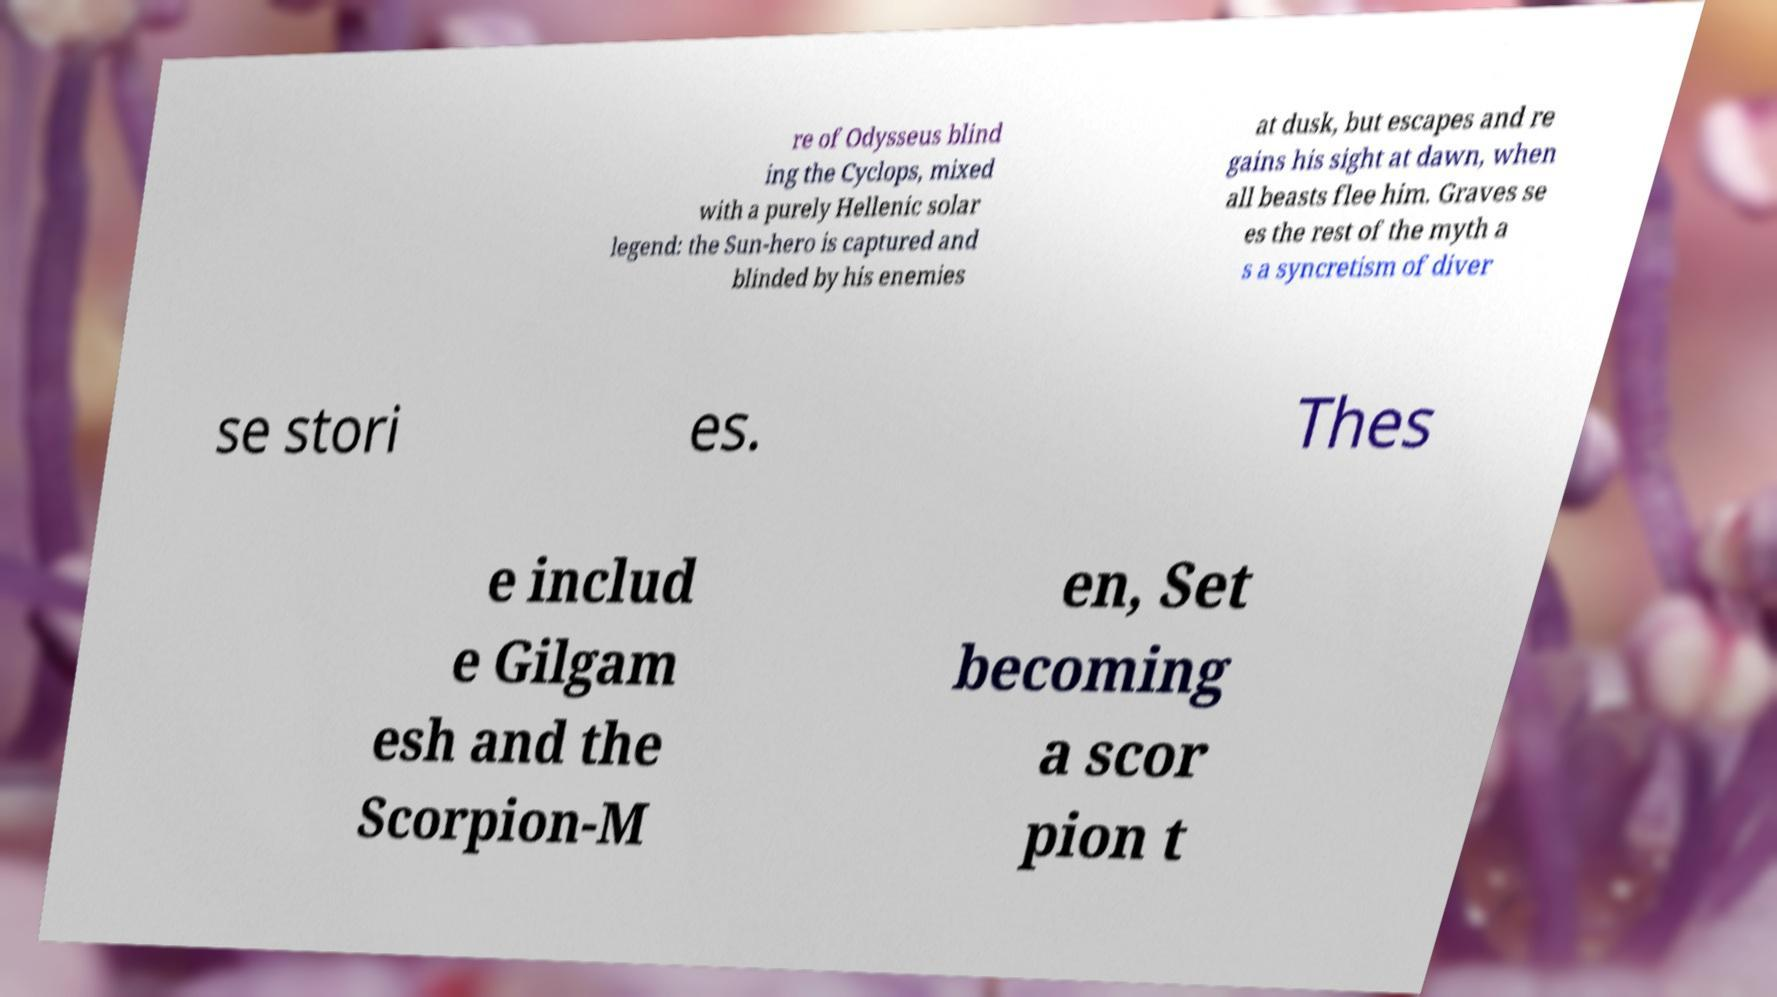For documentation purposes, I need the text within this image transcribed. Could you provide that? re of Odysseus blind ing the Cyclops, mixed with a purely Hellenic solar legend: the Sun-hero is captured and blinded by his enemies at dusk, but escapes and re gains his sight at dawn, when all beasts flee him. Graves se es the rest of the myth a s a syncretism of diver se stori es. Thes e includ e Gilgam esh and the Scorpion-M en, Set becoming a scor pion t 